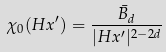<formula> <loc_0><loc_0><loc_500><loc_500>\chi _ { 0 } ( H x ^ { \prime } ) = \frac { { \bar { B } } _ { d } } { | H x ^ { \prime } | ^ { 2 - 2 d } }</formula> 